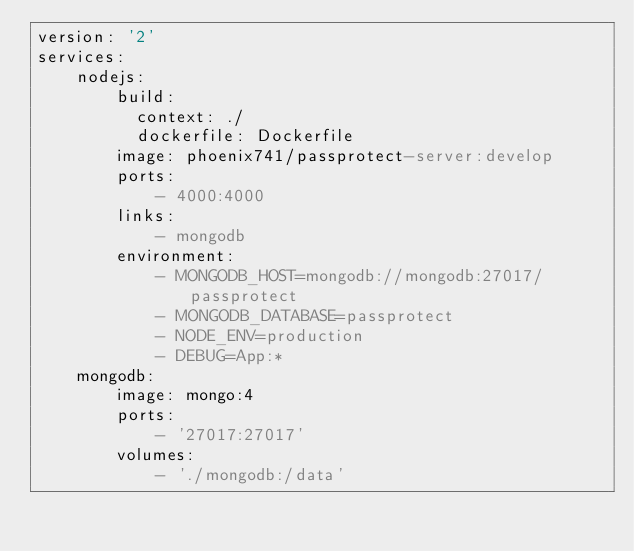<code> <loc_0><loc_0><loc_500><loc_500><_YAML_>version: '2'
services:
    nodejs:
        build:
          context: ./
          dockerfile: Dockerfile
        image: phoenix741/passprotect-server:develop
        ports:
            - 4000:4000
        links:
            - mongodb
        environment:
            - MONGODB_HOST=mongodb://mongodb:27017/passprotect
            - MONGODB_DATABASE=passprotect
            - NODE_ENV=production
            - DEBUG=App:*
    mongodb:
        image: mongo:4
        ports:
            - '27017:27017'
        volumes:
            - './mongodb:/data'
</code> 